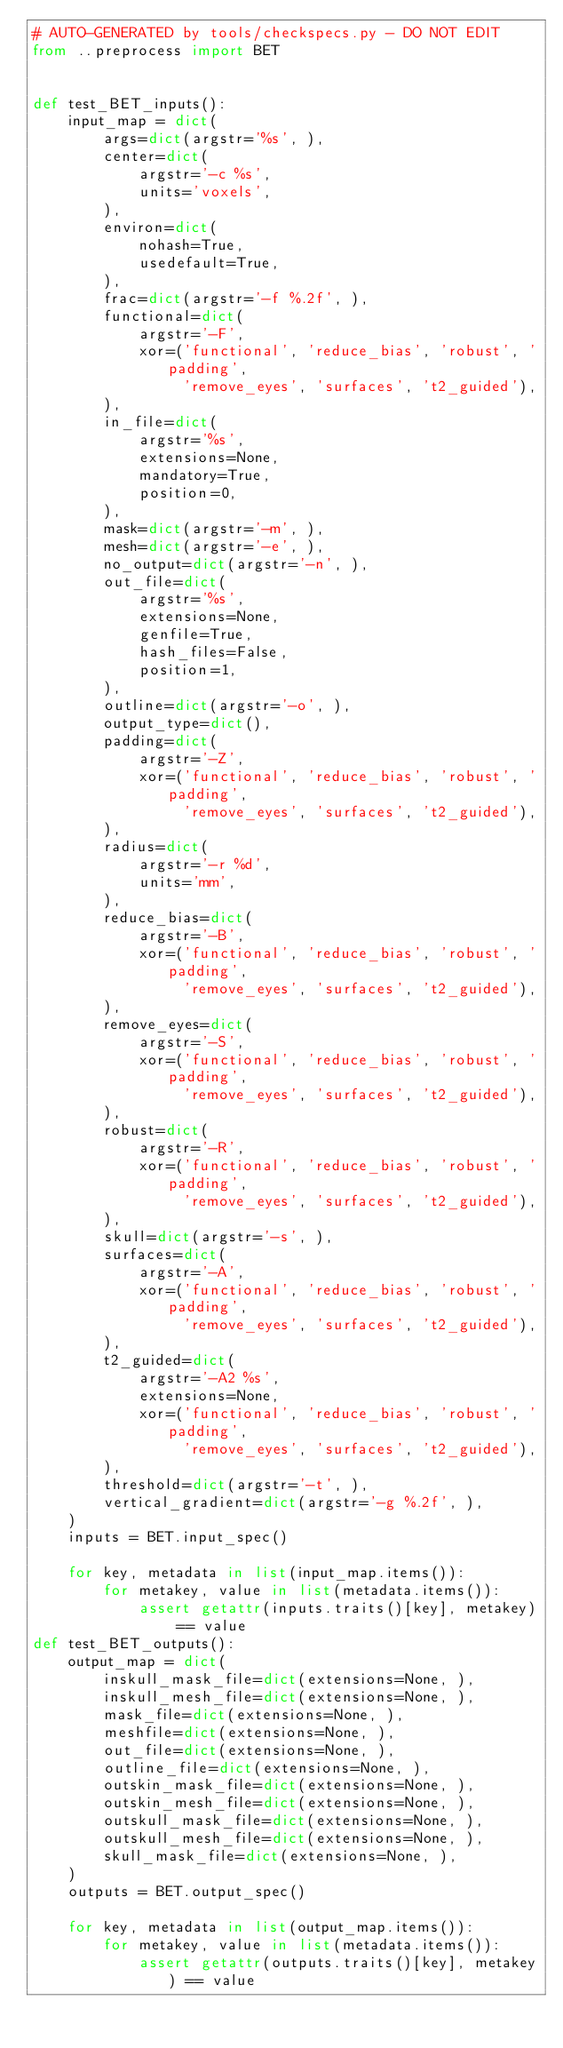Convert code to text. <code><loc_0><loc_0><loc_500><loc_500><_Python_># AUTO-GENERATED by tools/checkspecs.py - DO NOT EDIT
from ..preprocess import BET


def test_BET_inputs():
    input_map = dict(
        args=dict(argstr='%s', ),
        center=dict(
            argstr='-c %s',
            units='voxels',
        ),
        environ=dict(
            nohash=True,
            usedefault=True,
        ),
        frac=dict(argstr='-f %.2f', ),
        functional=dict(
            argstr='-F',
            xor=('functional', 'reduce_bias', 'robust', 'padding',
                 'remove_eyes', 'surfaces', 't2_guided'),
        ),
        in_file=dict(
            argstr='%s',
            extensions=None,
            mandatory=True,
            position=0,
        ),
        mask=dict(argstr='-m', ),
        mesh=dict(argstr='-e', ),
        no_output=dict(argstr='-n', ),
        out_file=dict(
            argstr='%s',
            extensions=None,
            genfile=True,
            hash_files=False,
            position=1,
        ),
        outline=dict(argstr='-o', ),
        output_type=dict(),
        padding=dict(
            argstr='-Z',
            xor=('functional', 'reduce_bias', 'robust', 'padding',
                 'remove_eyes', 'surfaces', 't2_guided'),
        ),
        radius=dict(
            argstr='-r %d',
            units='mm',
        ),
        reduce_bias=dict(
            argstr='-B',
            xor=('functional', 'reduce_bias', 'robust', 'padding',
                 'remove_eyes', 'surfaces', 't2_guided'),
        ),
        remove_eyes=dict(
            argstr='-S',
            xor=('functional', 'reduce_bias', 'robust', 'padding',
                 'remove_eyes', 'surfaces', 't2_guided'),
        ),
        robust=dict(
            argstr='-R',
            xor=('functional', 'reduce_bias', 'robust', 'padding',
                 'remove_eyes', 'surfaces', 't2_guided'),
        ),
        skull=dict(argstr='-s', ),
        surfaces=dict(
            argstr='-A',
            xor=('functional', 'reduce_bias', 'robust', 'padding',
                 'remove_eyes', 'surfaces', 't2_guided'),
        ),
        t2_guided=dict(
            argstr='-A2 %s',
            extensions=None,
            xor=('functional', 'reduce_bias', 'robust', 'padding',
                 'remove_eyes', 'surfaces', 't2_guided'),
        ),
        threshold=dict(argstr='-t', ),
        vertical_gradient=dict(argstr='-g %.2f', ),
    )
    inputs = BET.input_spec()

    for key, metadata in list(input_map.items()):
        for metakey, value in list(metadata.items()):
            assert getattr(inputs.traits()[key], metakey) == value
def test_BET_outputs():
    output_map = dict(
        inskull_mask_file=dict(extensions=None, ),
        inskull_mesh_file=dict(extensions=None, ),
        mask_file=dict(extensions=None, ),
        meshfile=dict(extensions=None, ),
        out_file=dict(extensions=None, ),
        outline_file=dict(extensions=None, ),
        outskin_mask_file=dict(extensions=None, ),
        outskin_mesh_file=dict(extensions=None, ),
        outskull_mask_file=dict(extensions=None, ),
        outskull_mesh_file=dict(extensions=None, ),
        skull_mask_file=dict(extensions=None, ),
    )
    outputs = BET.output_spec()

    for key, metadata in list(output_map.items()):
        for metakey, value in list(metadata.items()):
            assert getattr(outputs.traits()[key], metakey) == value
</code> 